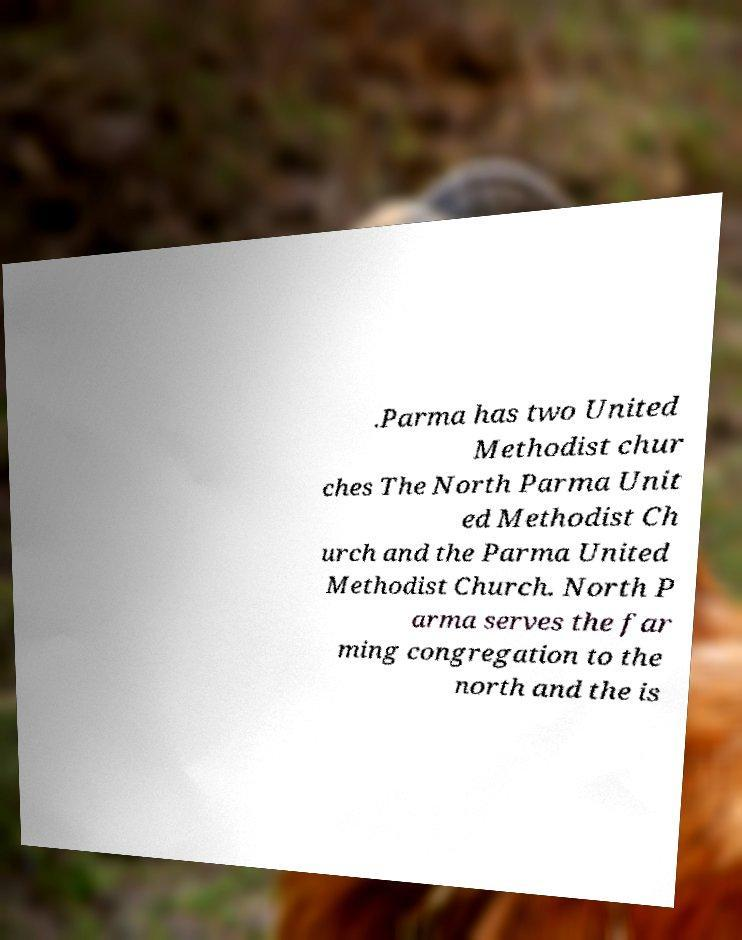What messages or text are displayed in this image? I need them in a readable, typed format. .Parma has two United Methodist chur ches The North Parma Unit ed Methodist Ch urch and the Parma United Methodist Church. North P arma serves the far ming congregation to the north and the is 